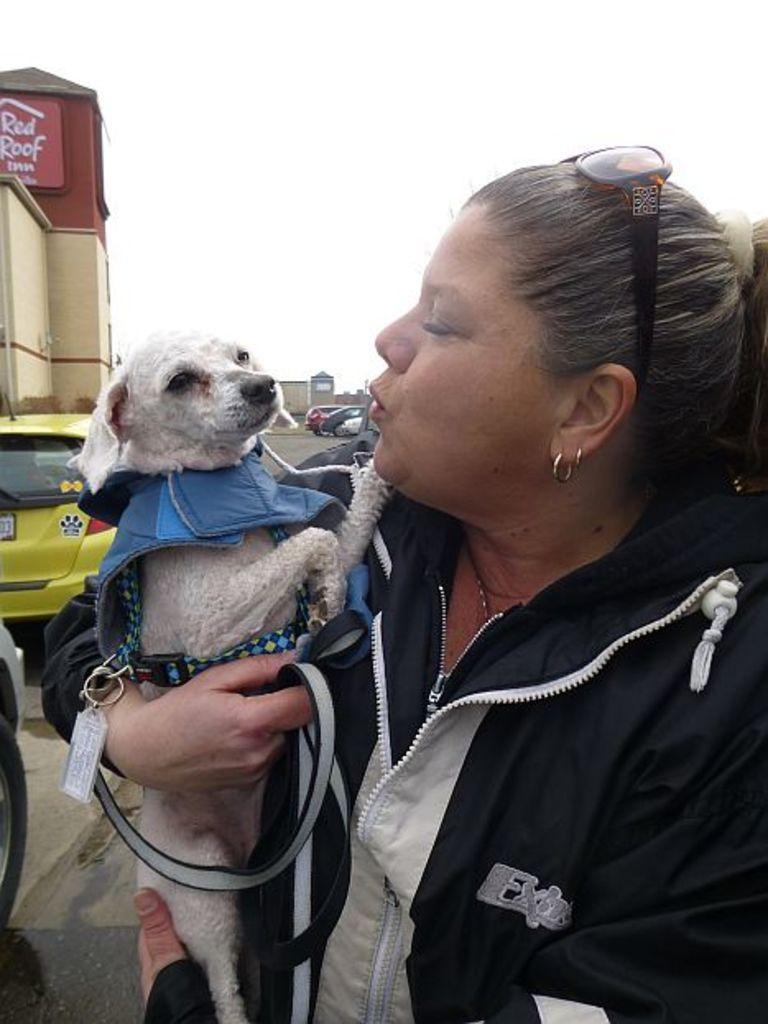Please provide a concise description of this image. In this image we can see a lady standing and holding a dog. In the background there are cars on the road and we can see buildings. At the top there is sky. 